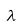Convert formula to latex. <formula><loc_0><loc_0><loc_500><loc_500>\lambda</formula> 